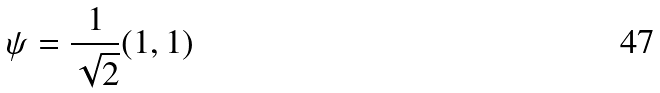Convert formula to latex. <formula><loc_0><loc_0><loc_500><loc_500>\psi = \frac { 1 } { \sqrt { 2 } } ( 1 , 1 )</formula> 